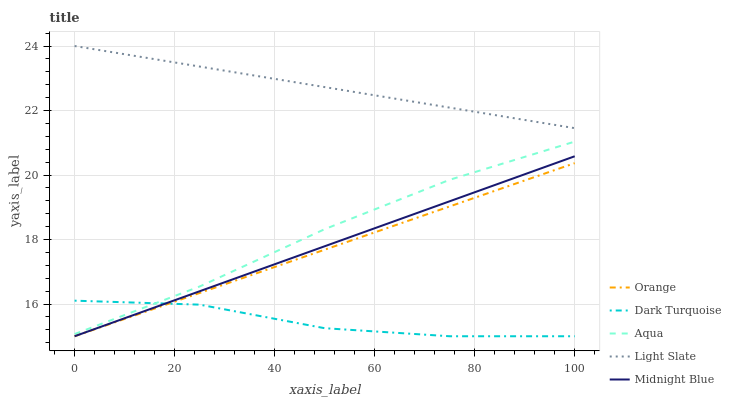Does Dark Turquoise have the minimum area under the curve?
Answer yes or no. Yes. Does Light Slate have the maximum area under the curve?
Answer yes or no. Yes. Does Aqua have the minimum area under the curve?
Answer yes or no. No. Does Aqua have the maximum area under the curve?
Answer yes or no. No. Is Midnight Blue the smoothest?
Answer yes or no. Yes. Is Dark Turquoise the roughest?
Answer yes or no. Yes. Is Aqua the smoothest?
Answer yes or no. No. Is Aqua the roughest?
Answer yes or no. No. Does Orange have the lowest value?
Answer yes or no. Yes. Does Aqua have the lowest value?
Answer yes or no. No. Does Light Slate have the highest value?
Answer yes or no. Yes. Does Aqua have the highest value?
Answer yes or no. No. Is Aqua less than Light Slate?
Answer yes or no. Yes. Is Light Slate greater than Aqua?
Answer yes or no. Yes. Does Orange intersect Midnight Blue?
Answer yes or no. Yes. Is Orange less than Midnight Blue?
Answer yes or no. No. Is Orange greater than Midnight Blue?
Answer yes or no. No. Does Aqua intersect Light Slate?
Answer yes or no. No. 